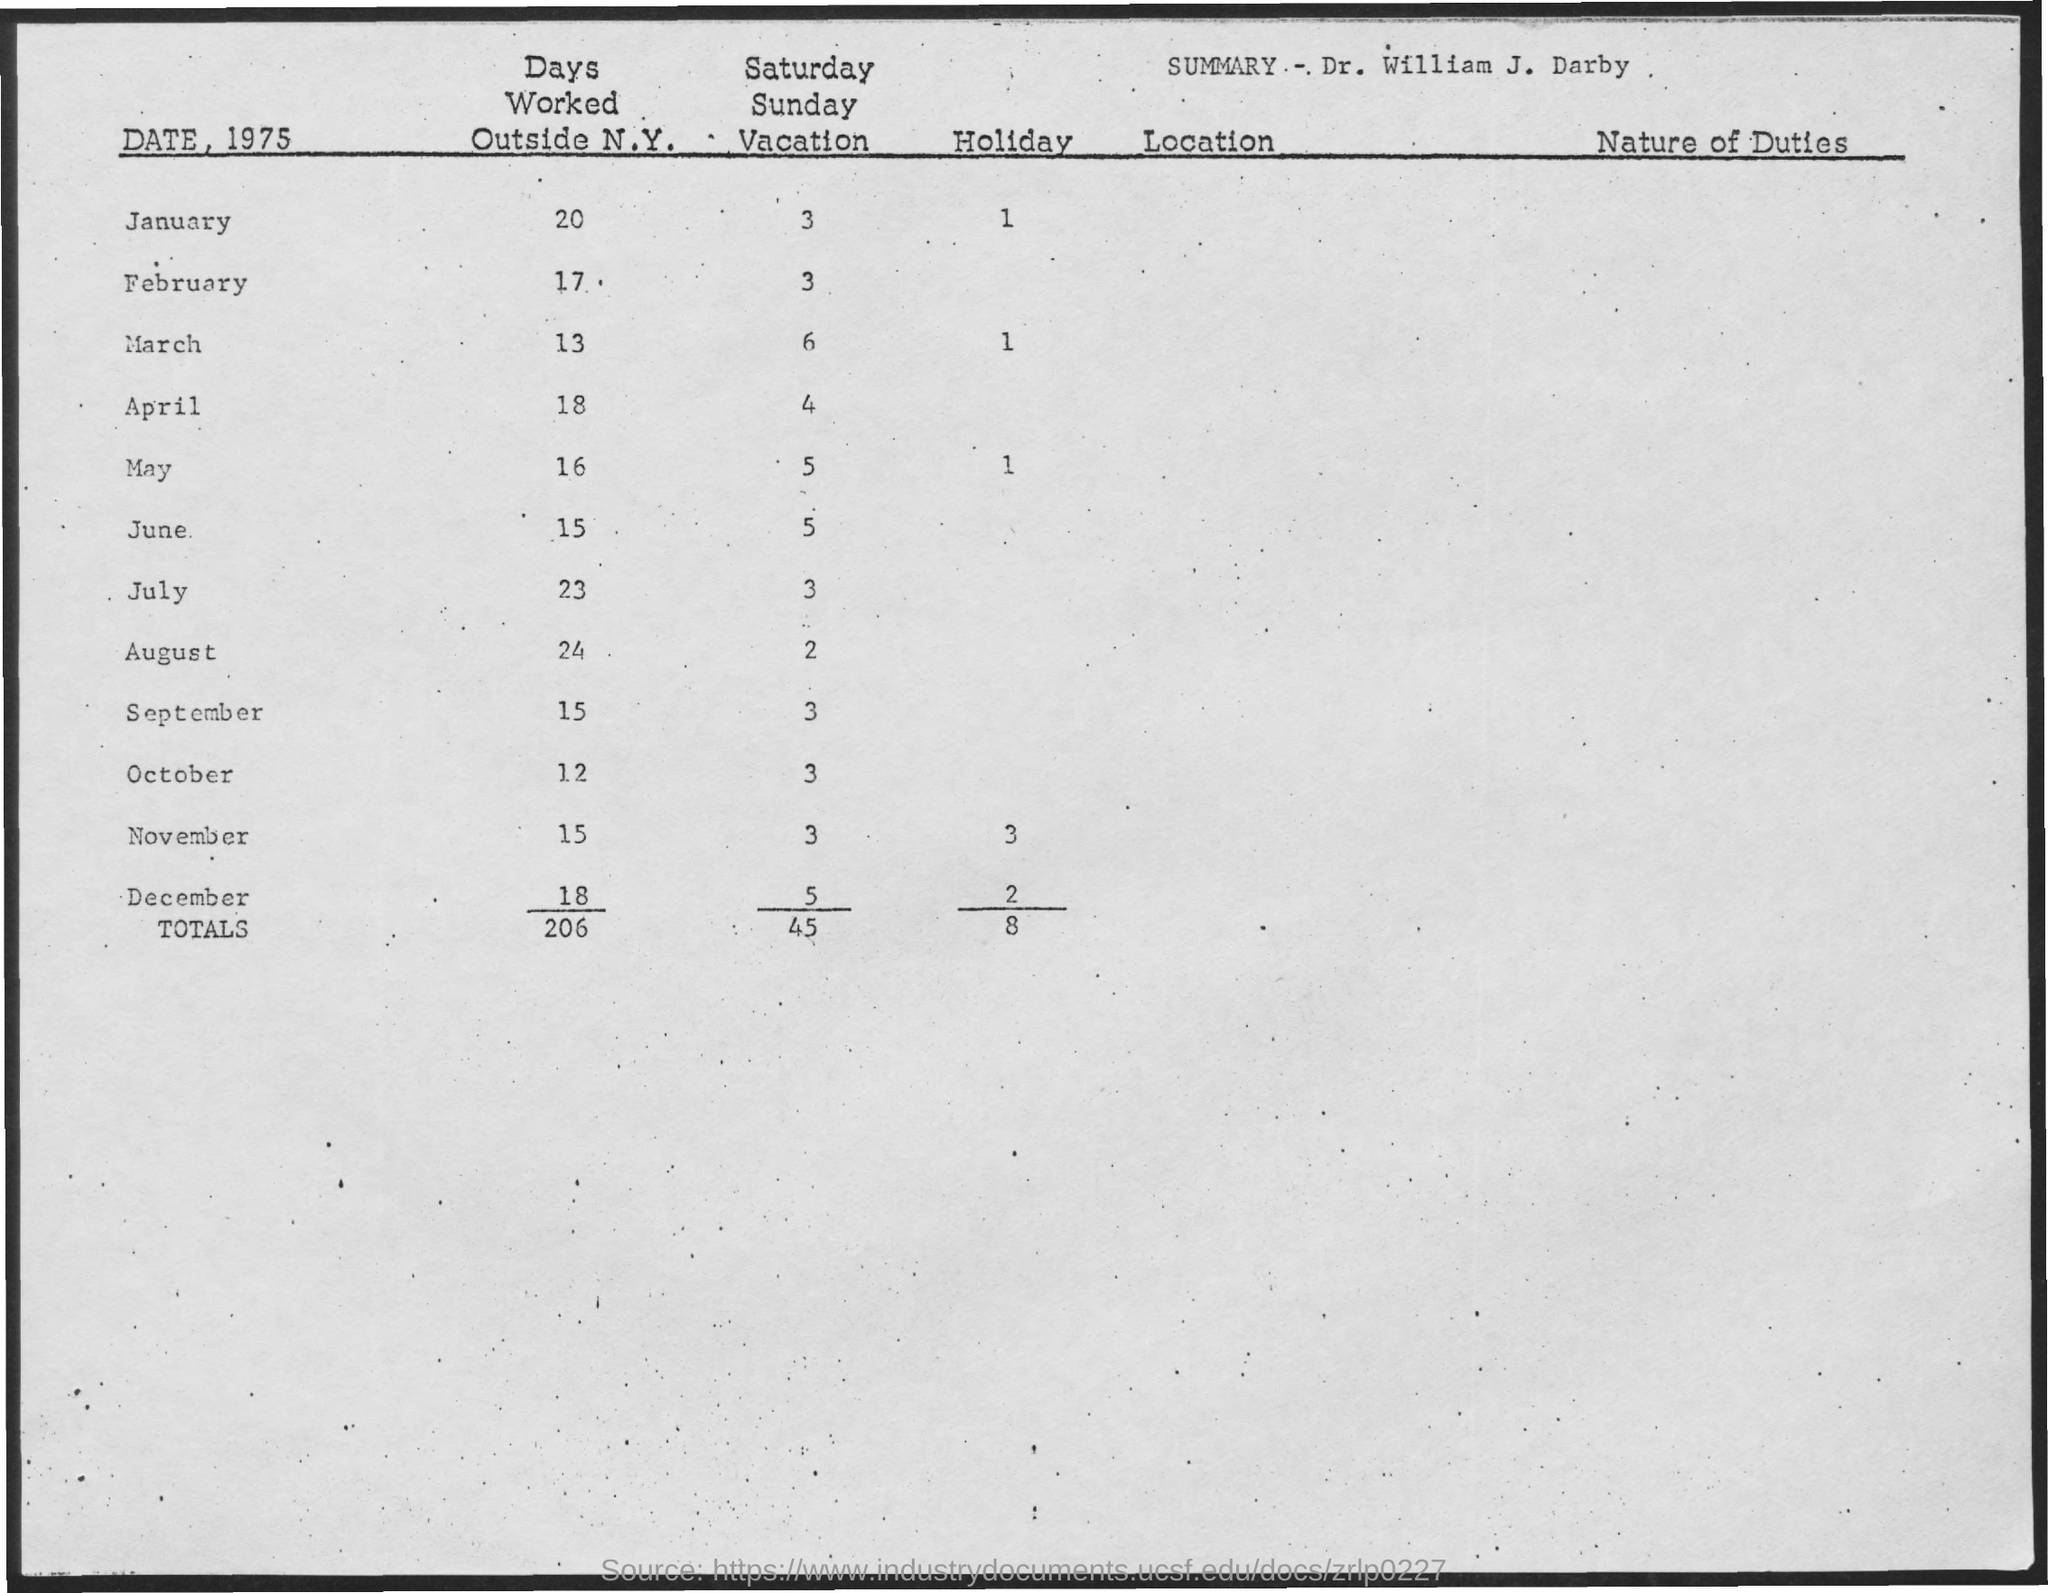Highlight a few significant elements in this photo. The total number of holidays is 8. The number of Saturday-Sunday in January is three. The number of days worked outside of New York in January is 20. There is only one holiday in January. There were 12 days worked outside of New York in the month of October. 